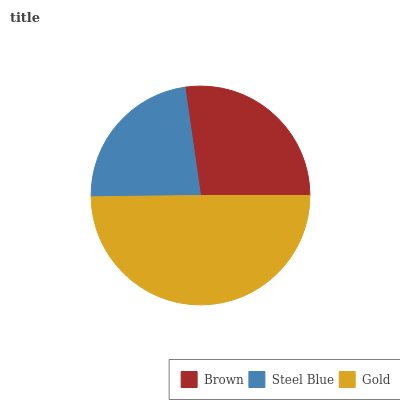Is Steel Blue the minimum?
Answer yes or no. Yes. Is Gold the maximum?
Answer yes or no. Yes. Is Gold the minimum?
Answer yes or no. No. Is Steel Blue the maximum?
Answer yes or no. No. Is Gold greater than Steel Blue?
Answer yes or no. Yes. Is Steel Blue less than Gold?
Answer yes or no. Yes. Is Steel Blue greater than Gold?
Answer yes or no. No. Is Gold less than Steel Blue?
Answer yes or no. No. Is Brown the high median?
Answer yes or no. Yes. Is Brown the low median?
Answer yes or no. Yes. Is Steel Blue the high median?
Answer yes or no. No. Is Steel Blue the low median?
Answer yes or no. No. 